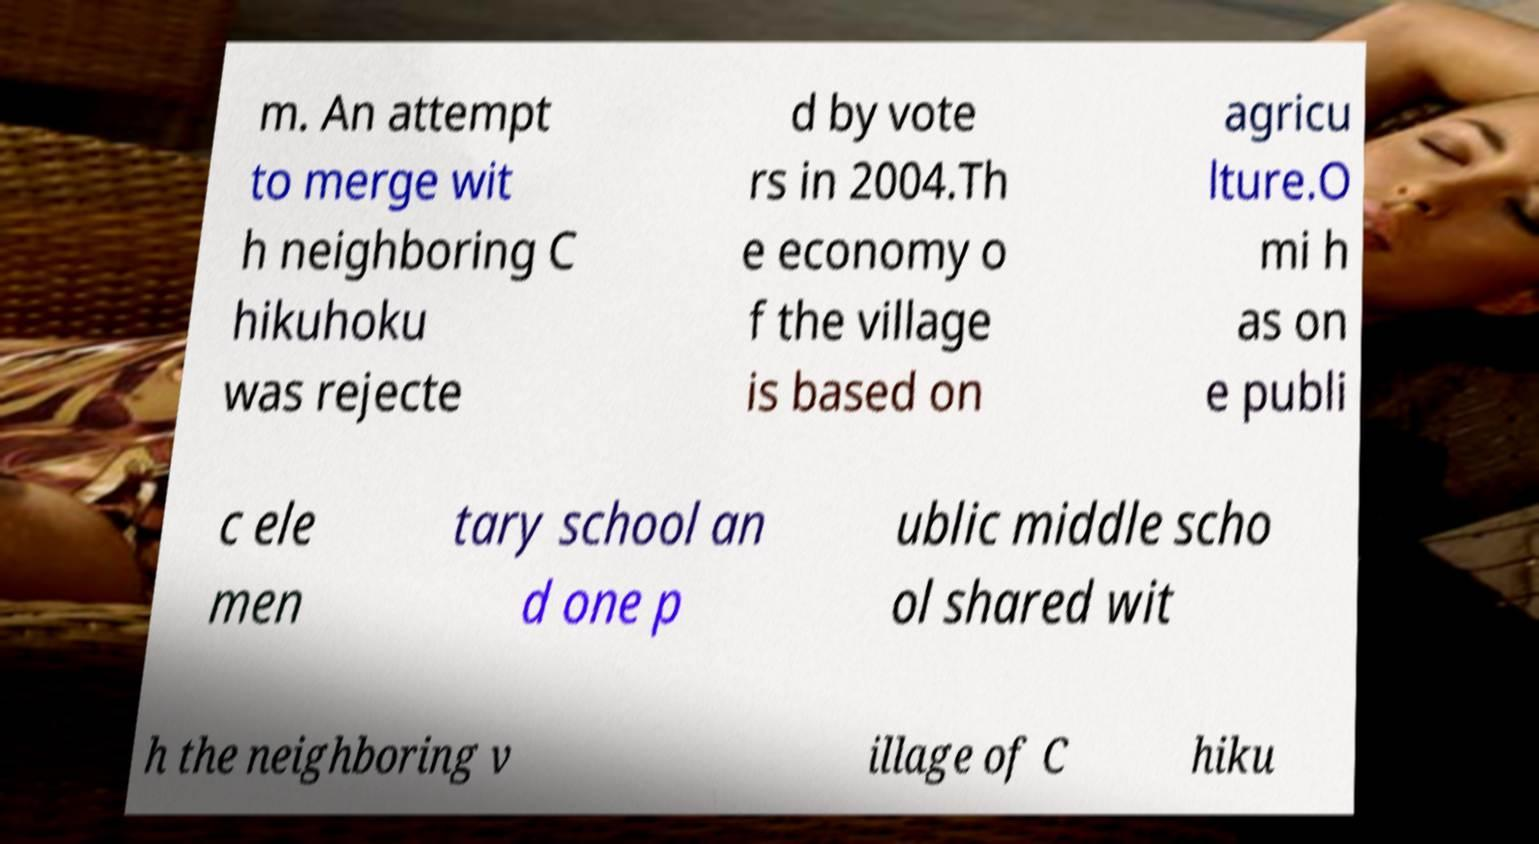What messages or text are displayed in this image? I need them in a readable, typed format. m. An attempt to merge wit h neighboring C hikuhoku was rejecte d by vote rs in 2004.Th e economy o f the village is based on agricu lture.O mi h as on e publi c ele men tary school an d one p ublic middle scho ol shared wit h the neighboring v illage of C hiku 